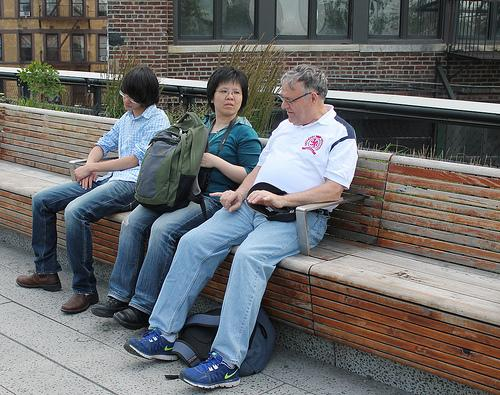What kind of object is the green and gray item in the image? The green and gray item is a backpack. Count the number of people in the image and describe their positions. There are three people sitting on a wooden bench - a young man, an old man, and a dark-haired woman. What type of footwear can be seen in the image, including colors and styles? Blue Nike tennis shoes with green check, green and blue shoes, brown shoes of a man, black shoes of a woman, and a pair of brown shoes. How are the people in the image interacting with each other? The people are sitting close to each other, but they seem to be not interacting directly, focused on their belongings. Briefly describe the scene displayed in the image. Three people are sitting on a wooden bench, with backpacks and personal belongings around them, on a sidewalk. What type of clothing is the man in the white shirt wearing? The man is wearing a white short-sleeved shirt with blue shoulder and a red design on the front. What can you infer about the personal belongings of the people in the image? They possess backpacks of various colors and styles, including green, blue, black, and gray, which suggests they might be carrying valuable items or necessities. Mention the color and brand of the tennis shoes in the image. The tennis shoes are blue Nike with a green check. Describe the overall sentiment or mood of the scene in the image. The scene is calm and relaxed, with people resting on a bench and taking care of their personal belongings. What is common between the eyeglasses of the young man, the old man, and the woman in the image? All three of them are wearing eyeglasses. 